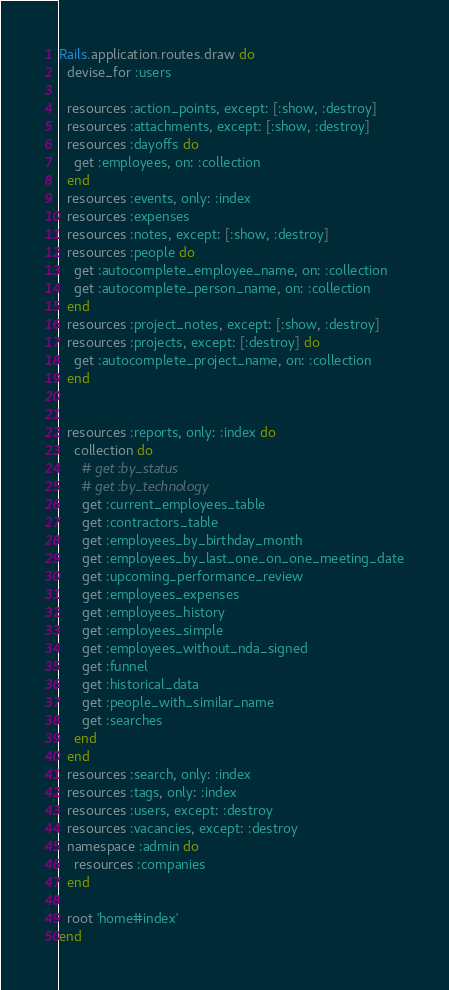Convert code to text. <code><loc_0><loc_0><loc_500><loc_500><_Ruby_>Rails.application.routes.draw do
  devise_for :users

  resources :action_points, except: [:show, :destroy]
  resources :attachments, except: [:show, :destroy]
  resources :dayoffs do
    get :employees, on: :collection
  end
  resources :events, only: :index
  resources :expenses
  resources :notes, except: [:show, :destroy]
  resources :people do
    get :autocomplete_employee_name, on: :collection
    get :autocomplete_person_name, on: :collection
  end
  resources :project_notes, except: [:show, :destroy]
  resources :projects, except: [:destroy] do
    get :autocomplete_project_name, on: :collection
  end


  resources :reports, only: :index do
    collection do
      # get :by_status
      # get :by_technology
      get :current_employees_table
      get :contractors_table
      get :employees_by_birthday_month
      get :employees_by_last_one_on_one_meeting_date
      get :upcoming_performance_review
      get :employees_expenses
      get :employees_history
      get :employees_simple
      get :employees_without_nda_signed
      get :funnel
      get :historical_data
      get :people_with_similar_name
      get :searches
    end
  end
  resources :search, only: :index
  resources :tags, only: :index
  resources :users, except: :destroy
  resources :vacancies, except: :destroy
  namespace :admin do
    resources :companies
  end

  root 'home#index'
end
</code> 